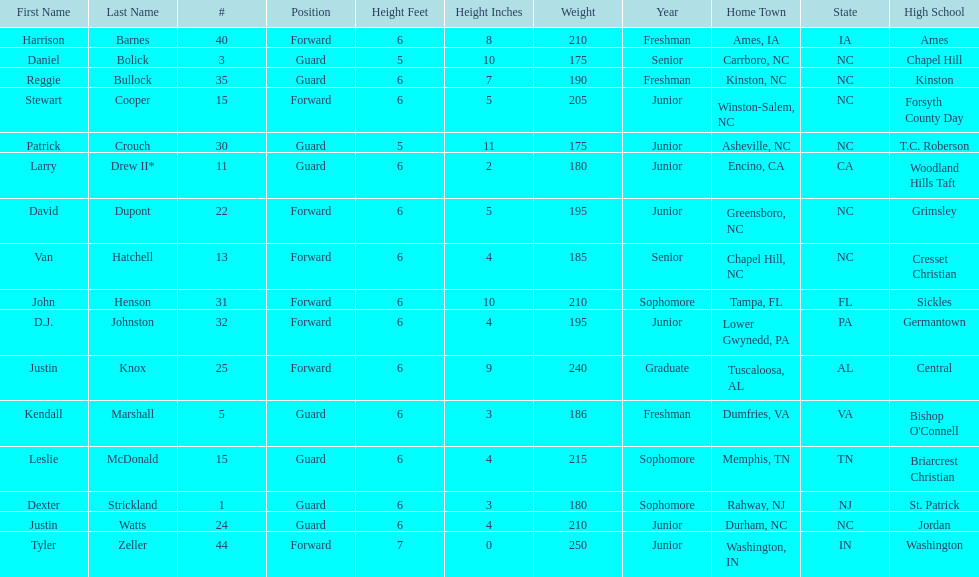Total number of players whose home town was in north carolina (nc) 7. 